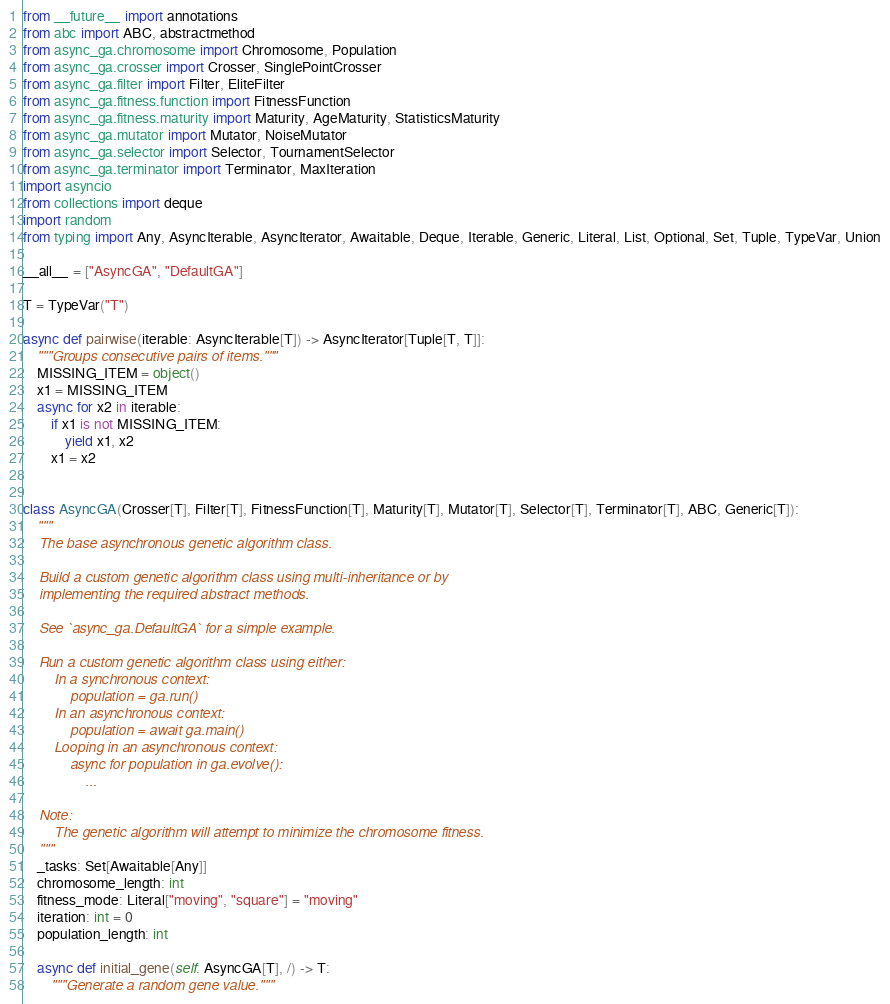<code> <loc_0><loc_0><loc_500><loc_500><_Python_>from __future__ import annotations
from abc import ABC, abstractmethod
from async_ga.chromosome import Chromosome, Population
from async_ga.crosser import Crosser, SinglePointCrosser
from async_ga.filter import Filter, EliteFilter
from async_ga.fitness.function import FitnessFunction
from async_ga.fitness.maturity import Maturity, AgeMaturity, StatisticsMaturity
from async_ga.mutator import Mutator, NoiseMutator
from async_ga.selector import Selector, TournamentSelector
from async_ga.terminator import Terminator, MaxIteration
import asyncio
from collections import deque
import random
from typing import Any, AsyncIterable, AsyncIterator, Awaitable, Deque, Iterable, Generic, Literal, List, Optional, Set, Tuple, TypeVar, Union

__all__ = ["AsyncGA", "DefaultGA"]

T = TypeVar("T")

async def pairwise(iterable: AsyncIterable[T]) -> AsyncIterator[Tuple[T, T]]:
    """Groups consecutive pairs of items."""
    MISSING_ITEM = object()
    x1 = MISSING_ITEM
    async for x2 in iterable:
        if x1 is not MISSING_ITEM:
            yield x1, x2
        x1 = x2


class AsyncGA(Crosser[T], Filter[T], FitnessFunction[T], Maturity[T], Mutator[T], Selector[T], Terminator[T], ABC, Generic[T]):
    """
    The base asynchronous genetic algorithm class.

    Build a custom genetic algorithm class using multi-inheritance or by
    implementing the required abstract methods.

    See `async_ga.DefaultGA` for a simple example.

    Run a custom genetic algorithm class using either:
        In a synchronous context:
            population = ga.run()
        In an asynchronous context:
            population = await ga.main()
        Looping in an asynchronous context:
            async for population in ga.evolve():
                ...

    Note:
        The genetic algorithm will attempt to minimize the chromosome fitness.
    """
    _tasks: Set[Awaitable[Any]]
    chromosome_length: int
    fitness_mode: Literal["moving", "square"] = "moving"
    iteration: int = 0
    population_length: int

    async def initial_gene(self: AsyncGA[T], /) -> T:
        """Generate a random gene value."""</code> 